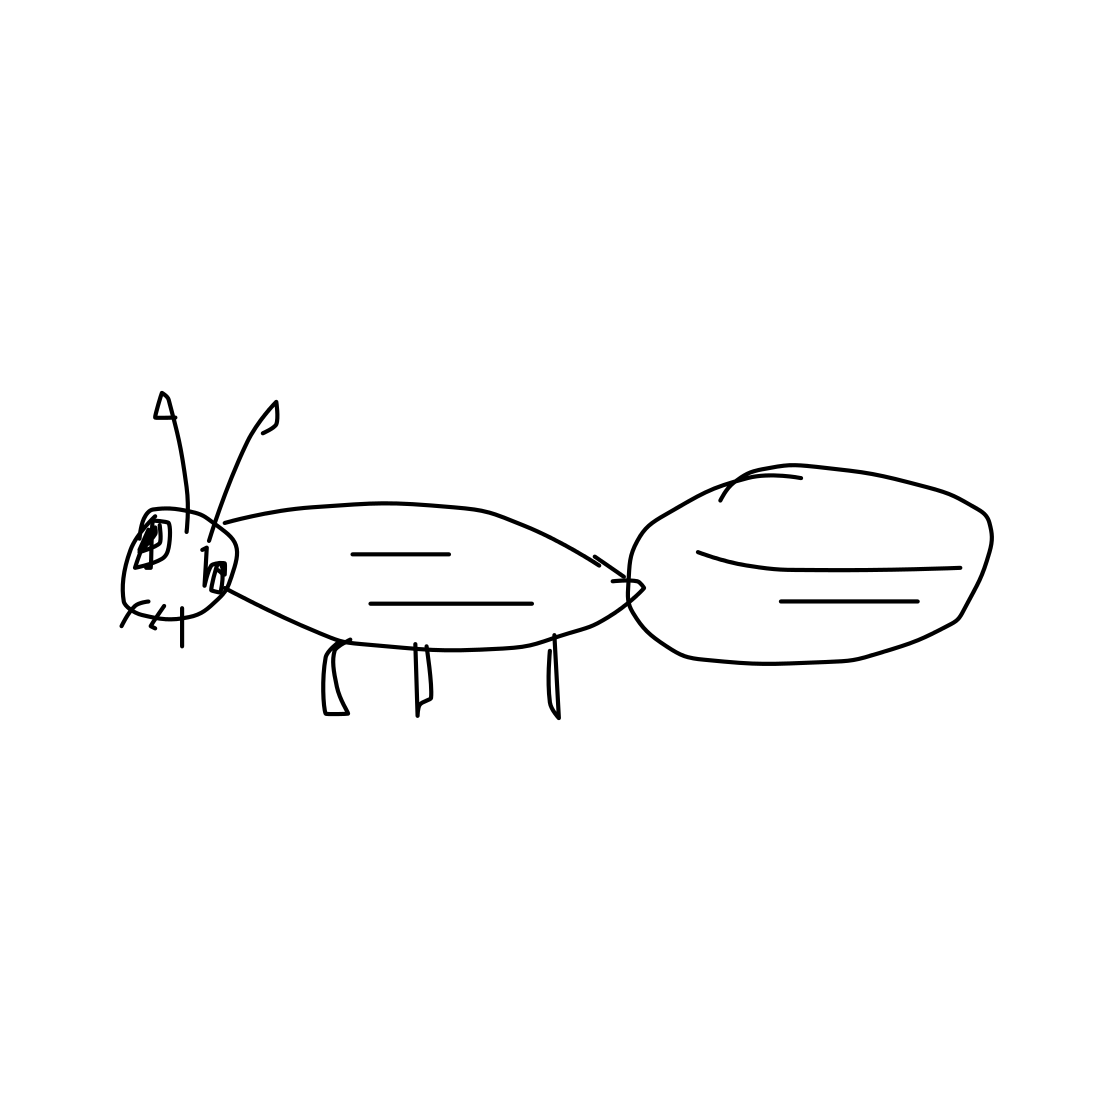Reflect on the artistic style and expression used in this ant sketch. The artistic style of this sketch is minimalist and functional, using unembellished lines to focus purely on form and proportion. This style strips down unnecessary details and emphasizes the essence of the organism, which can be particularly effective in educational settings where clarity is prioritized over artistic flair. The expression in this drawing, while basic, effectively communicates the essential structure of an ant, making it easily recognizable and understandable. 